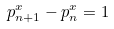<formula> <loc_0><loc_0><loc_500><loc_500>p _ { n + 1 } ^ { x } - p _ { n } ^ { x } = 1</formula> 